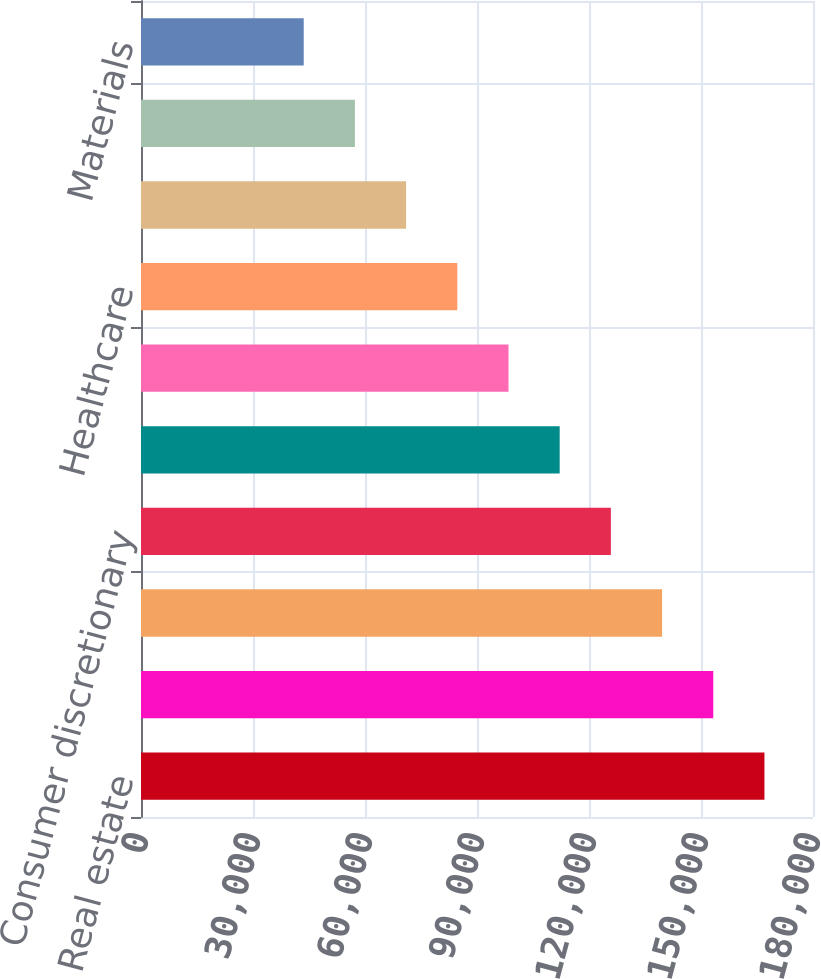<chart> <loc_0><loc_0><loc_500><loc_500><bar_chart><fcel>Real estate<fcel>Financials 1<fcel>Information technology<fcel>Consumer discretionary<fcel>Industrials<fcel>Energy<fcel>Healthcare<fcel>Utilities<fcel>Consumer staples<fcel>Materials<nl><fcel>166995<fcel>153283<fcel>139571<fcel>125859<fcel>112147<fcel>98434.7<fcel>84722.6<fcel>71010.5<fcel>57298.4<fcel>43586.3<nl></chart> 